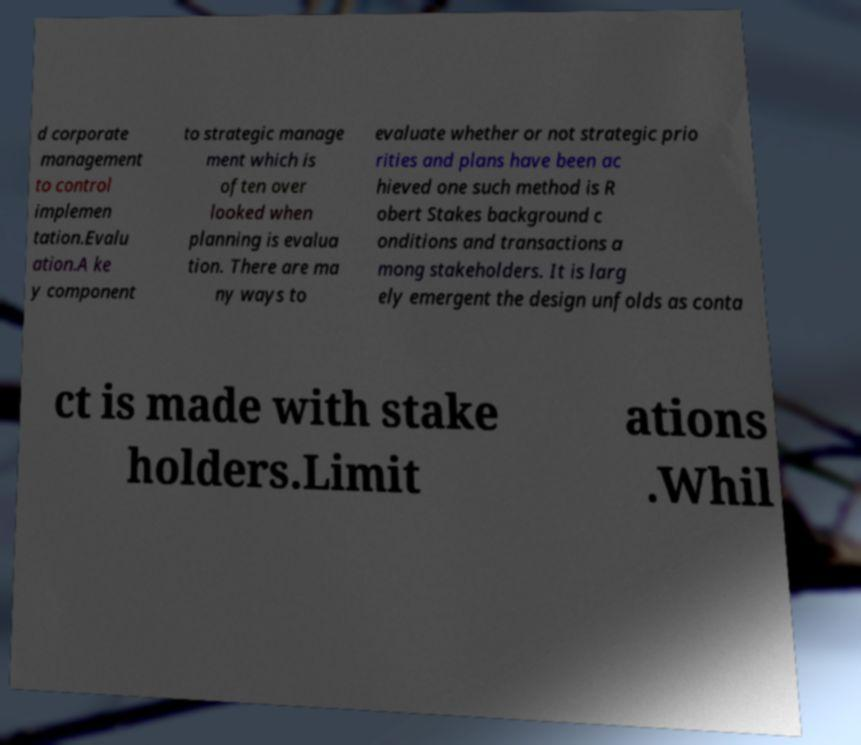For documentation purposes, I need the text within this image transcribed. Could you provide that? d corporate management to control implemen tation.Evalu ation.A ke y component to strategic manage ment which is often over looked when planning is evalua tion. There are ma ny ways to evaluate whether or not strategic prio rities and plans have been ac hieved one such method is R obert Stakes background c onditions and transactions a mong stakeholders. It is larg ely emergent the design unfolds as conta ct is made with stake holders.Limit ations .Whil 